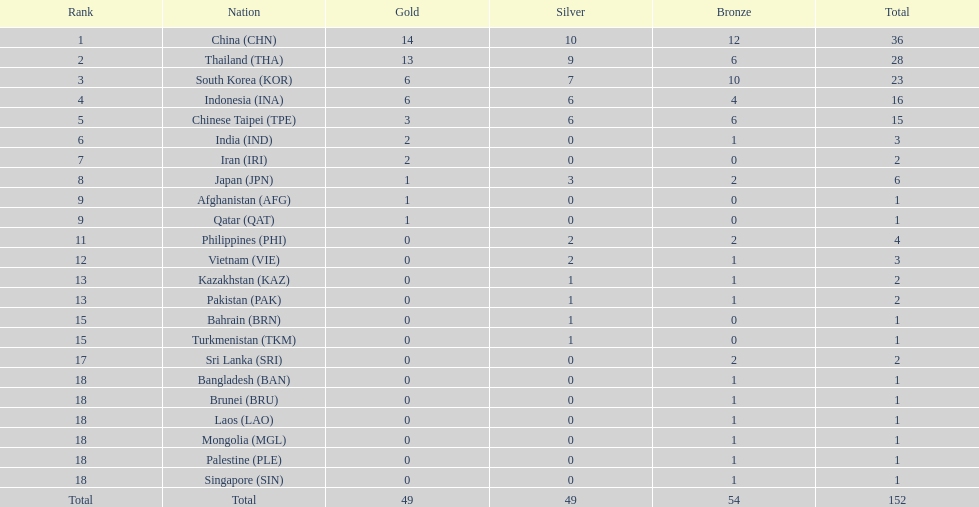Which countries won the same number of gold medals as japan? Afghanistan (AFG), Qatar (QAT). 